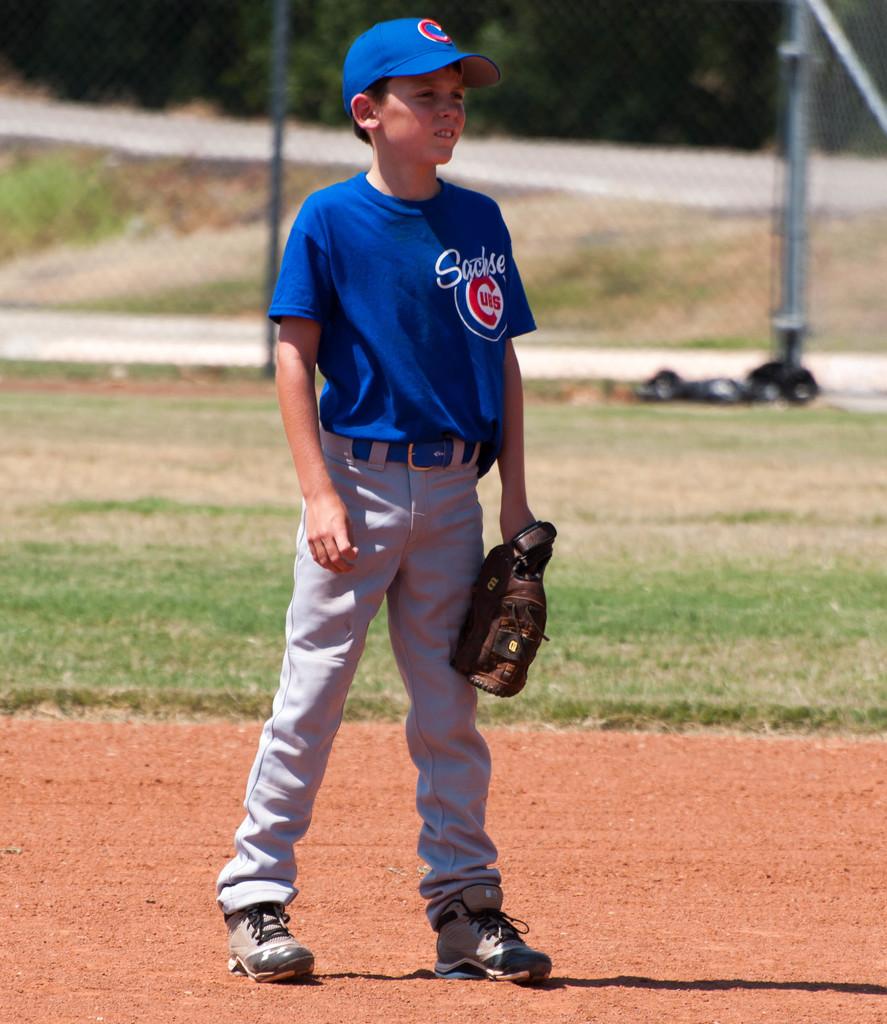Is that one of the cubs players?
Your answer should be very brief. Yes. What letter is on the player's hat?
Offer a very short reply. C. 